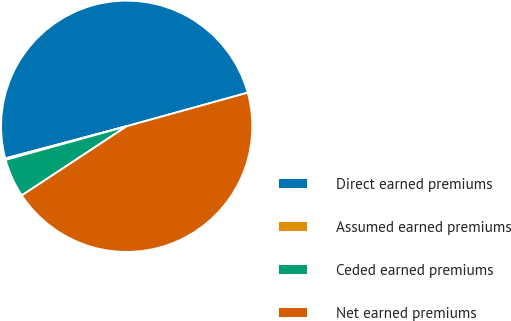<chart> <loc_0><loc_0><loc_500><loc_500><pie_chart><fcel>Direct earned premiums<fcel>Assumed earned premiums<fcel>Ceded earned premiums<fcel>Net earned premiums<nl><fcel>49.82%<fcel>0.18%<fcel>4.97%<fcel>45.03%<nl></chart> 